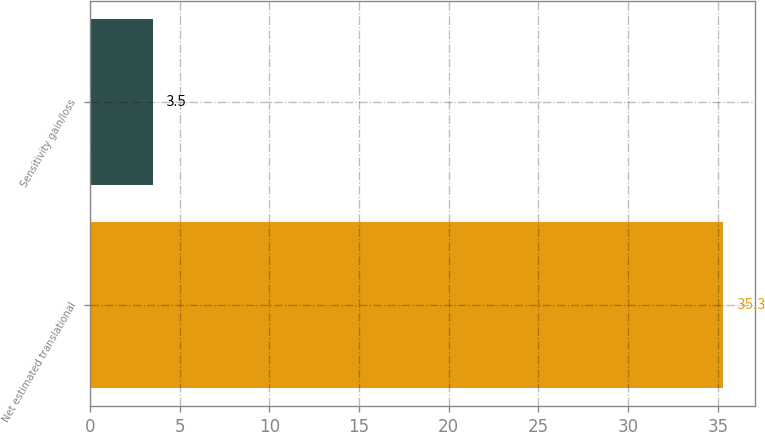Convert chart. <chart><loc_0><loc_0><loc_500><loc_500><bar_chart><fcel>Net estimated translational<fcel>Sensitivity gain/loss<nl><fcel>35.3<fcel>3.5<nl></chart> 